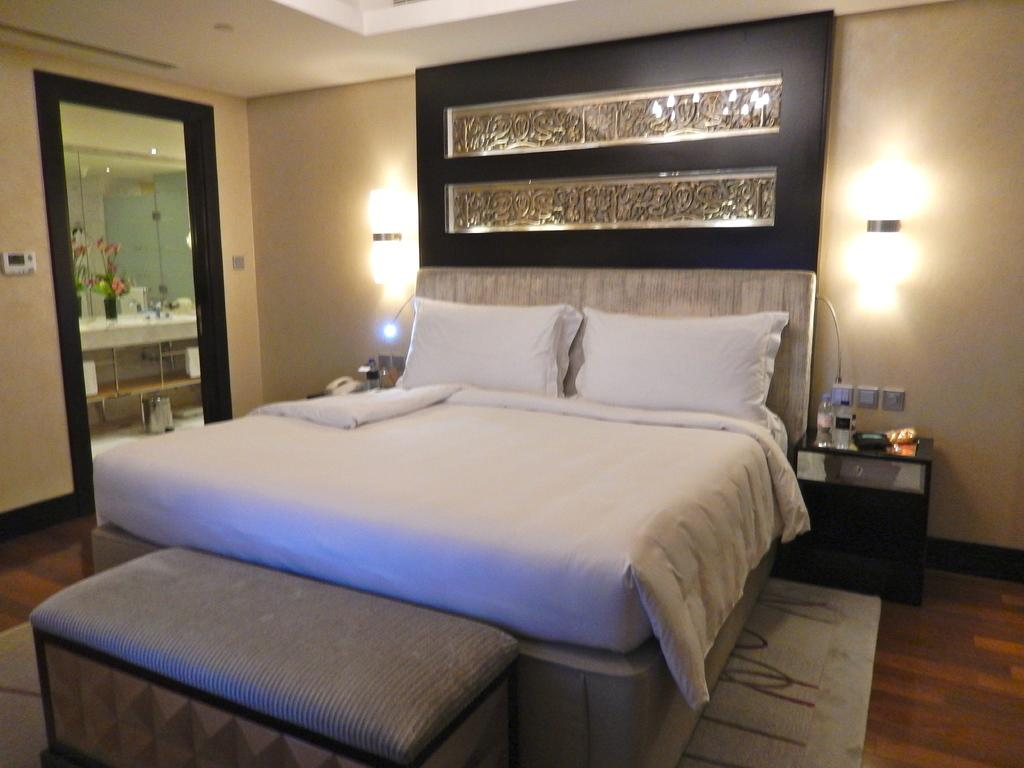What type of furniture is present in the image? There is a bed, a table, and a couch in the image. What can be seen on the wall in the image? There are lights on the wall in the image. What is another item present in the room? There is a mirror in the image. Can you see anyone using a nail to fix something in the image? There is no indication of anyone using a nail or fixing anything in the image. Is there a fire visible in the image? There is no fire present in the image. 